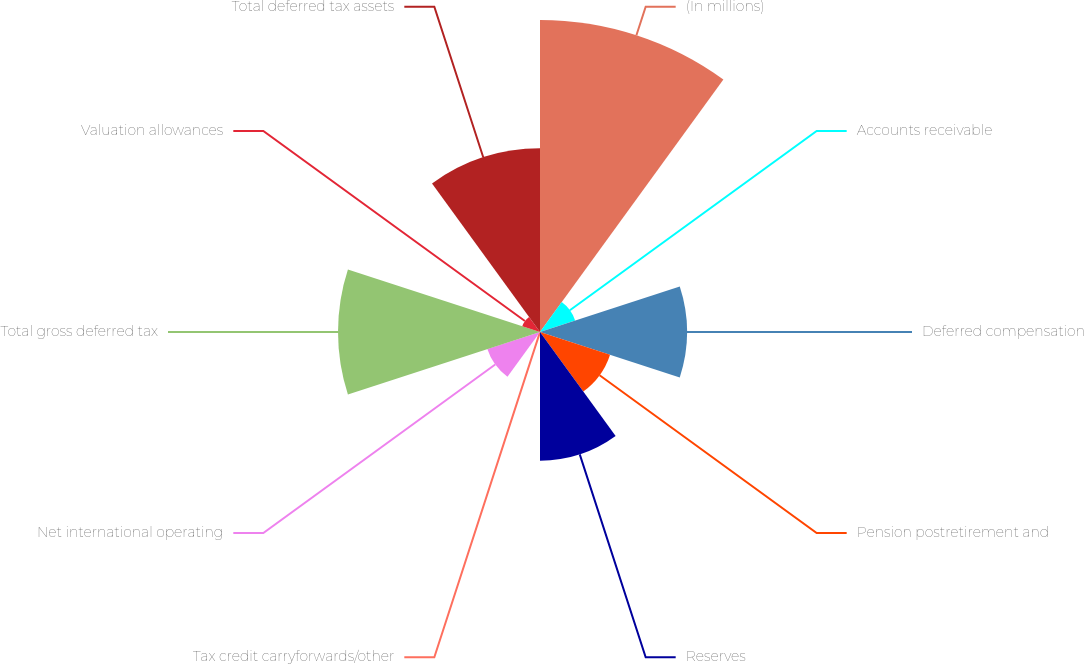Convert chart. <chart><loc_0><loc_0><loc_500><loc_500><pie_chart><fcel>(In millions)<fcel>Accounts receivable<fcel>Deferred compensation<fcel>Pension postretirement and<fcel>Reserves<fcel>Tax credit carryforwards/other<fcel>Net international operating<fcel>Total gross deferred tax<fcel>Valuation allowances<fcel>Total deferred tax assets<nl><fcel>26.94%<fcel>3.19%<fcel>12.69%<fcel>6.36%<fcel>11.11%<fcel>0.03%<fcel>4.78%<fcel>17.44%<fcel>1.61%<fcel>15.86%<nl></chart> 